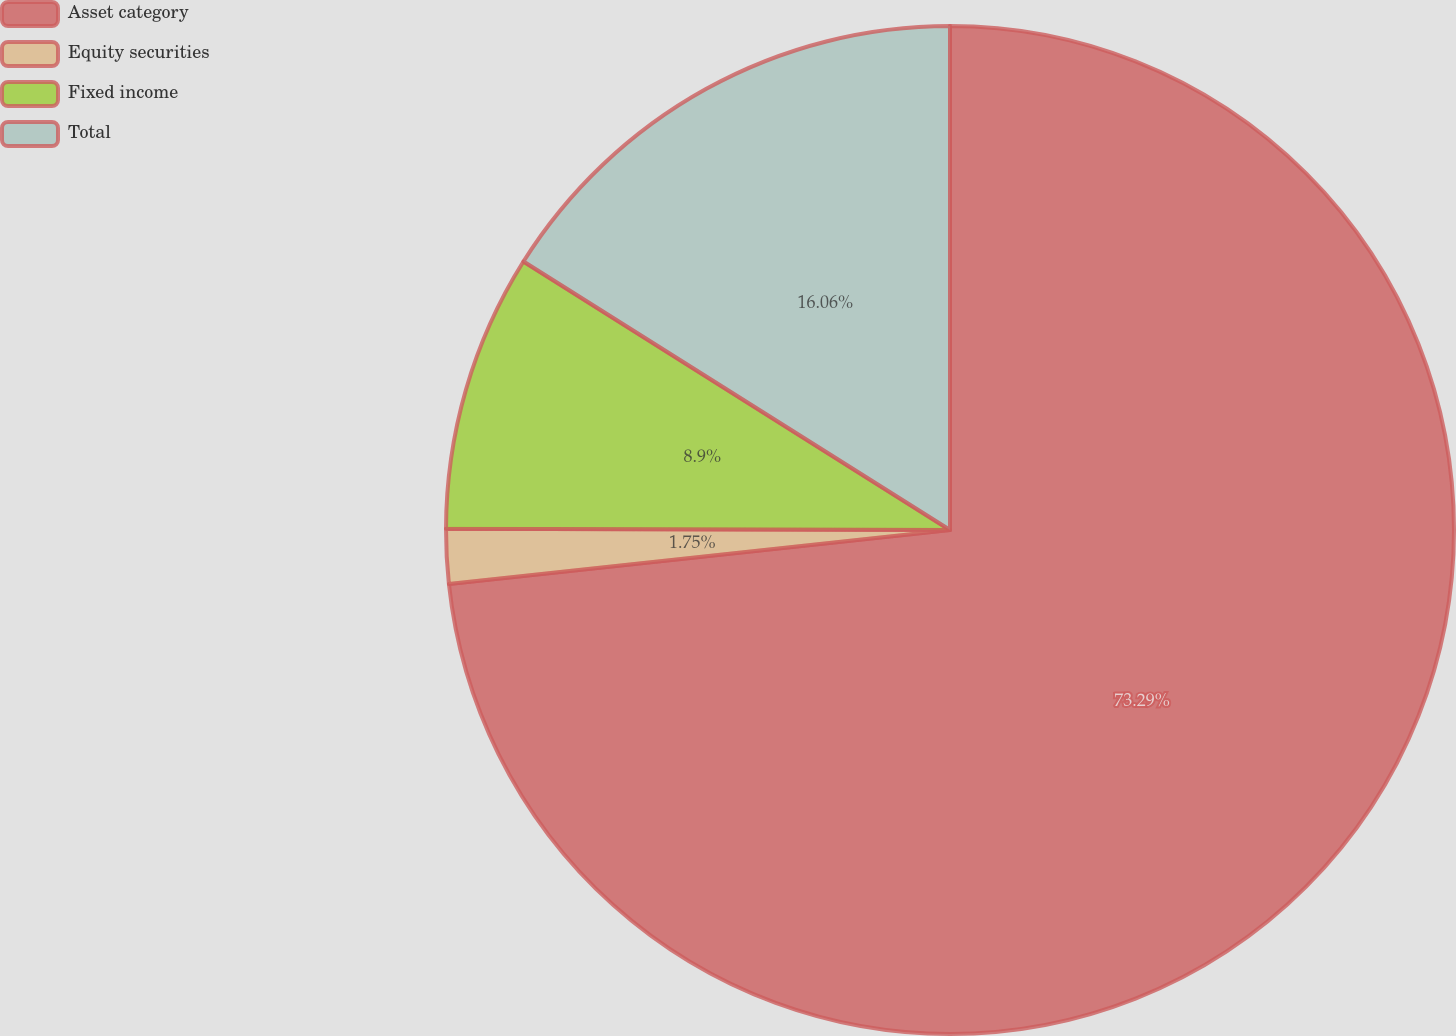<chart> <loc_0><loc_0><loc_500><loc_500><pie_chart><fcel>Asset category<fcel>Equity securities<fcel>Fixed income<fcel>Total<nl><fcel>73.29%<fcel>1.75%<fcel>8.9%<fcel>16.06%<nl></chart> 